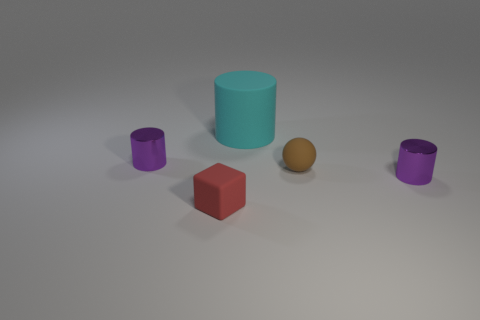Add 4 big cylinders. How many objects exist? 9 Subtract all small metallic cylinders. How many cylinders are left? 1 Subtract 1 cylinders. How many cylinders are left? 2 Subtract all purple cylinders. How many cylinders are left? 1 Subtract all purple blocks. How many purple spheres are left? 0 Subtract all red cubes. Subtract all large cyan things. How many objects are left? 3 Add 5 tiny red objects. How many tiny red objects are left? 6 Add 5 rubber spheres. How many rubber spheres exist? 6 Subtract 0 blue spheres. How many objects are left? 5 Subtract all balls. How many objects are left? 4 